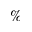<formula> <loc_0><loc_0><loc_500><loc_500>\%</formula> 